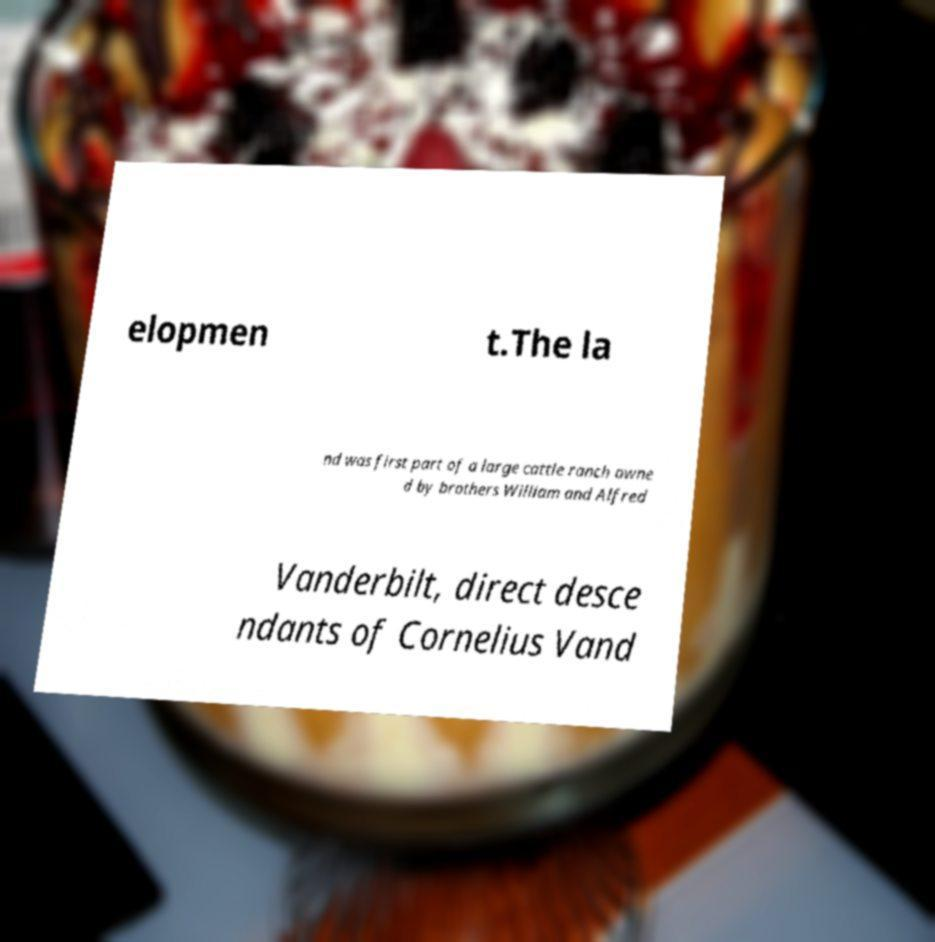Could you extract and type out the text from this image? elopmen t.The la nd was first part of a large cattle ranch owne d by brothers William and Alfred Vanderbilt, direct desce ndants of Cornelius Vand 